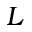<formula> <loc_0><loc_0><loc_500><loc_500>L</formula> 